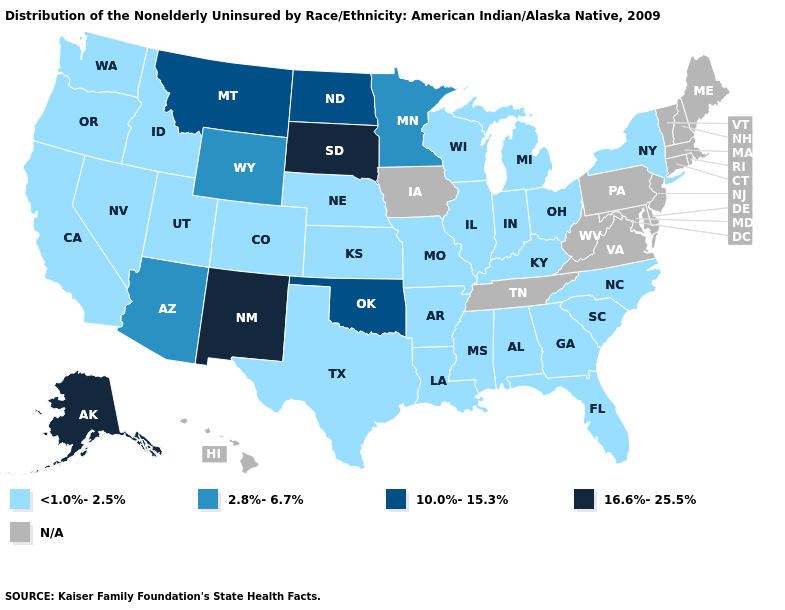What is the highest value in states that border Wisconsin?
Give a very brief answer. 2.8%-6.7%. What is the lowest value in the West?
Quick response, please. <1.0%-2.5%. Name the states that have a value in the range <1.0%-2.5%?
Concise answer only. Alabama, Arkansas, California, Colorado, Florida, Georgia, Idaho, Illinois, Indiana, Kansas, Kentucky, Louisiana, Michigan, Mississippi, Missouri, Nebraska, Nevada, New York, North Carolina, Ohio, Oregon, South Carolina, Texas, Utah, Washington, Wisconsin. What is the highest value in the USA?
Write a very short answer. 16.6%-25.5%. Name the states that have a value in the range 2.8%-6.7%?
Short answer required. Arizona, Minnesota, Wyoming. Does Minnesota have the lowest value in the USA?
Give a very brief answer. No. Does Oklahoma have the highest value in the South?
Quick response, please. Yes. Name the states that have a value in the range 2.8%-6.7%?
Be succinct. Arizona, Minnesota, Wyoming. Name the states that have a value in the range 10.0%-15.3%?
Short answer required. Montana, North Dakota, Oklahoma. What is the value of Colorado?
Be succinct. <1.0%-2.5%. Name the states that have a value in the range 10.0%-15.3%?
Keep it brief. Montana, North Dakota, Oklahoma. Name the states that have a value in the range 16.6%-25.5%?
Keep it brief. Alaska, New Mexico, South Dakota. What is the lowest value in the Northeast?
Concise answer only. <1.0%-2.5%. Which states hav the highest value in the Northeast?
Give a very brief answer. New York. 